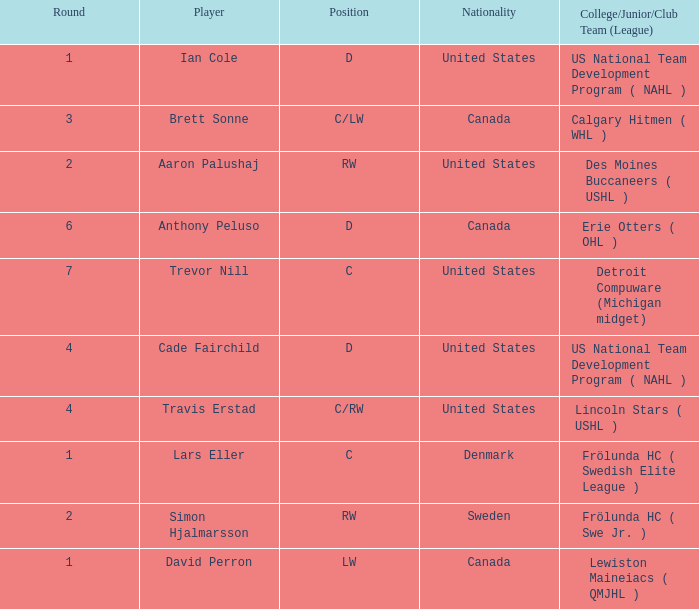Who is the player from Denmark who plays position c? Lars Eller. 